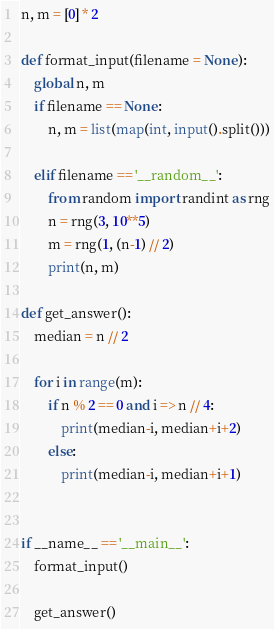<code> <loc_0><loc_0><loc_500><loc_500><_Python_>

n, m = [0] * 2

def format_input(filename = None):
	global n, m
	if filename == None:
		n, m = list(map(int, input().split()))

	elif filename == '__random__':
		from random import randint as rng
		n = rng(3, 10**5)
		m = rng(1, (n-1) // 2)
		print(n, m)

def get_answer():
	median = n // 2

	for i in range(m):
		if n % 2 == 0 and i => n // 4:
			print(median-i, median+i+2)
		else:
			print(median-i, median+i+1)


if __name__ == '__main__':
	format_input()

	get_answer()
</code> 